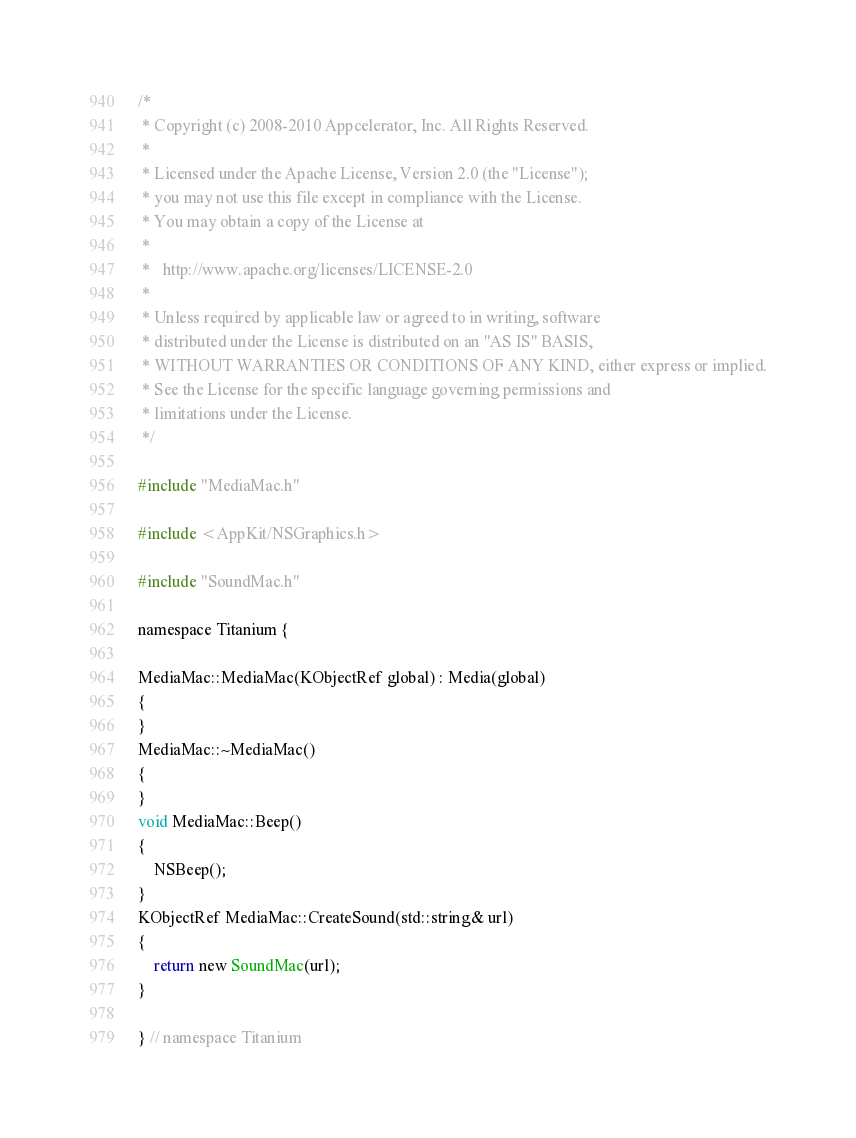Convert code to text. <code><loc_0><loc_0><loc_500><loc_500><_ObjectiveC_>/*
 * Copyright (c) 2008-2010 Appcelerator, Inc. All Rights Reserved.
 *
 * Licensed under the Apache License, Version 2.0 (the "License");
 * you may not use this file except in compliance with the License.
 * You may obtain a copy of the License at
 *
 *   http://www.apache.org/licenses/LICENSE-2.0
 *
 * Unless required by applicable law or agreed to in writing, software
 * distributed under the License is distributed on an "AS IS" BASIS,
 * WITHOUT WARRANTIES OR CONDITIONS OF ANY KIND, either express or implied.
 * See the License for the specific language governing permissions and
 * limitations under the License.
 */

#include "MediaMac.h"

#include <AppKit/NSGraphics.h>

#include "SoundMac.h"

namespace Titanium {

MediaMac::MediaMac(KObjectRef global) : Media(global)
{
}
MediaMac::~MediaMac()
{
}
void MediaMac::Beep()
{
    NSBeep();
}
KObjectRef MediaMac::CreateSound(std::string& url)
{
    return new SoundMac(url);
}

} // namespace Titanium
</code> 